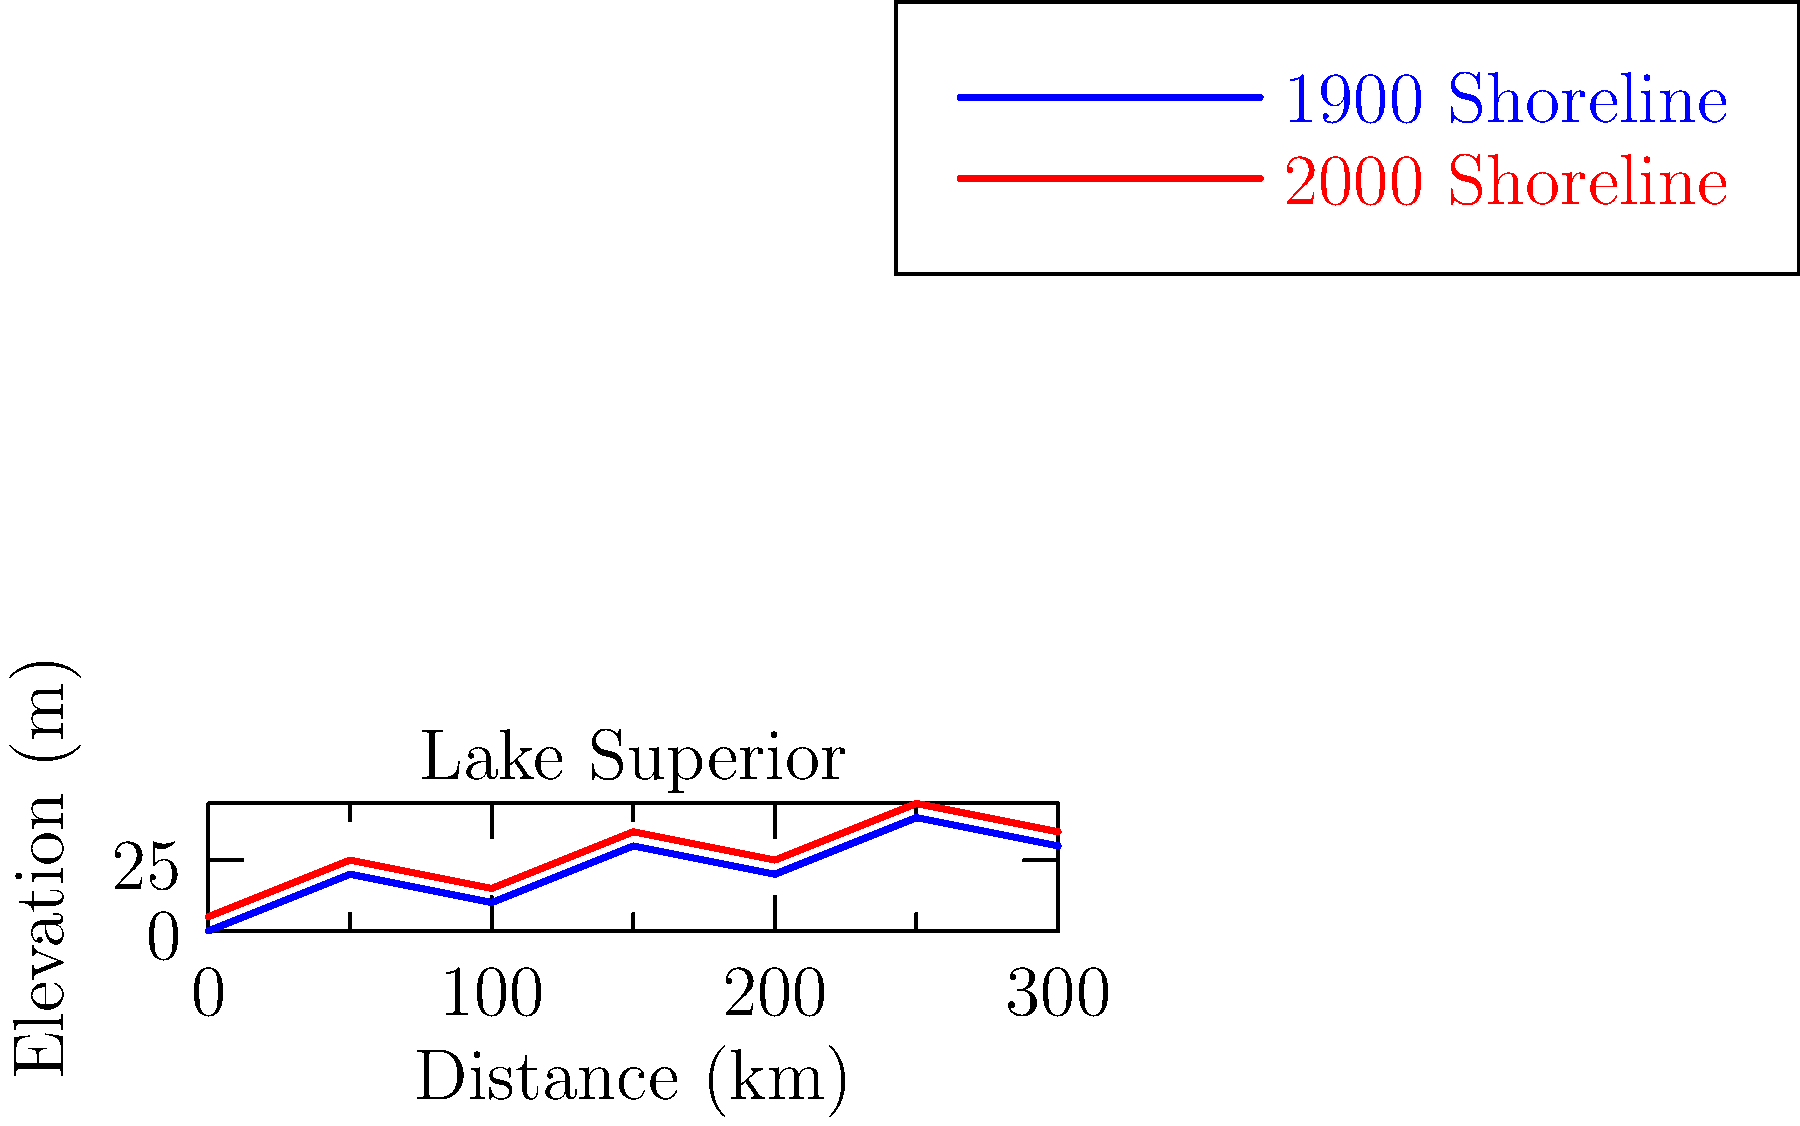Based on the overlaid historical maps of Lake Superior's shoreline from 1900 and 2000, what is the primary trend observed in the shoreline changes, and how might this relate to local geological processes in the Two Harbors area? To answer this question, we need to analyze the graph and consider the geological context of the Two Harbors area:

1. Observe the graph: The red line (2000 shoreline) is consistently above the blue line (1900 shoreline).

2. Interpret the change: This indicates that the shoreline has generally moved upward and slightly inland over the past century.

3. Calculate the average change: The vertical distance between the lines is approximately 5 meters throughout the graph.

4. Consider geological processes:
   a) Isostatic rebound: The Two Harbors area, like much of the Lake Superior region, is experiencing post-glacial rebound.
   b) This process occurs as the land slowly rises after being depressed by the weight of glaciers during the last ice age.

5. Connect to local history: Two Harbors, being on the North Shore of Lake Superior, would be particularly affected by this geological process.

6. Impact on shoreline: As the land rises due to isostatic rebound, it appears as if the water level is dropping, causing the shoreline to move outward and upward.

7. Additional factors: While isostatic rebound is likely the primary cause, other factors like erosion and human activities (e.g., harbor construction) may also contribute to localized changes.

The primary trend observed is an upward shift in the shoreline, which is consistent with the process of isostatic rebound affecting the Two Harbors area and the broader Lake Superior region.
Answer: Upward shoreline shift due to isostatic rebound 